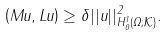<formula> <loc_0><loc_0><loc_500><loc_500>\left ( M u , L u \right ) \geq \delta | | u | | _ { H ^ { 1 } _ { 0 } \left ( \Omega ; \mathcal { K } \right ) } ^ { 2 } .</formula> 